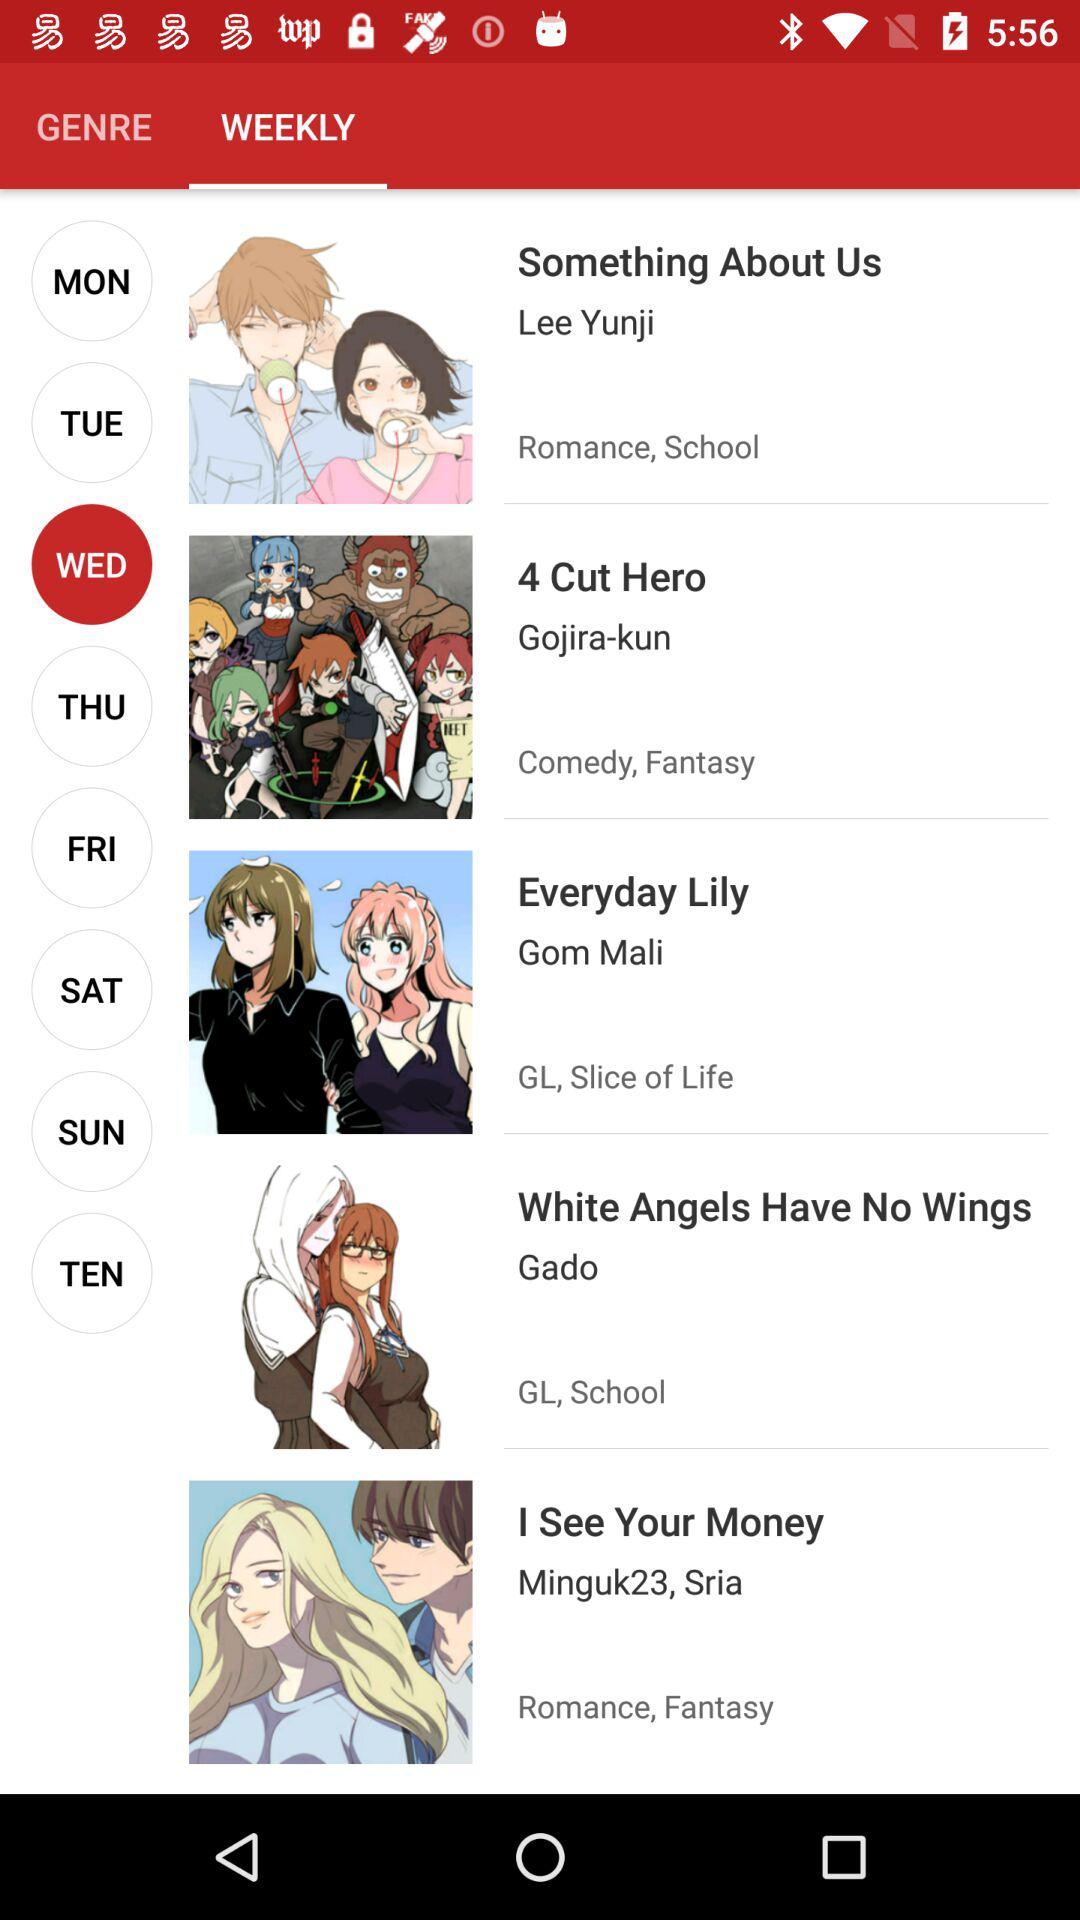Which day is selected? The selected day is Wednesday. 